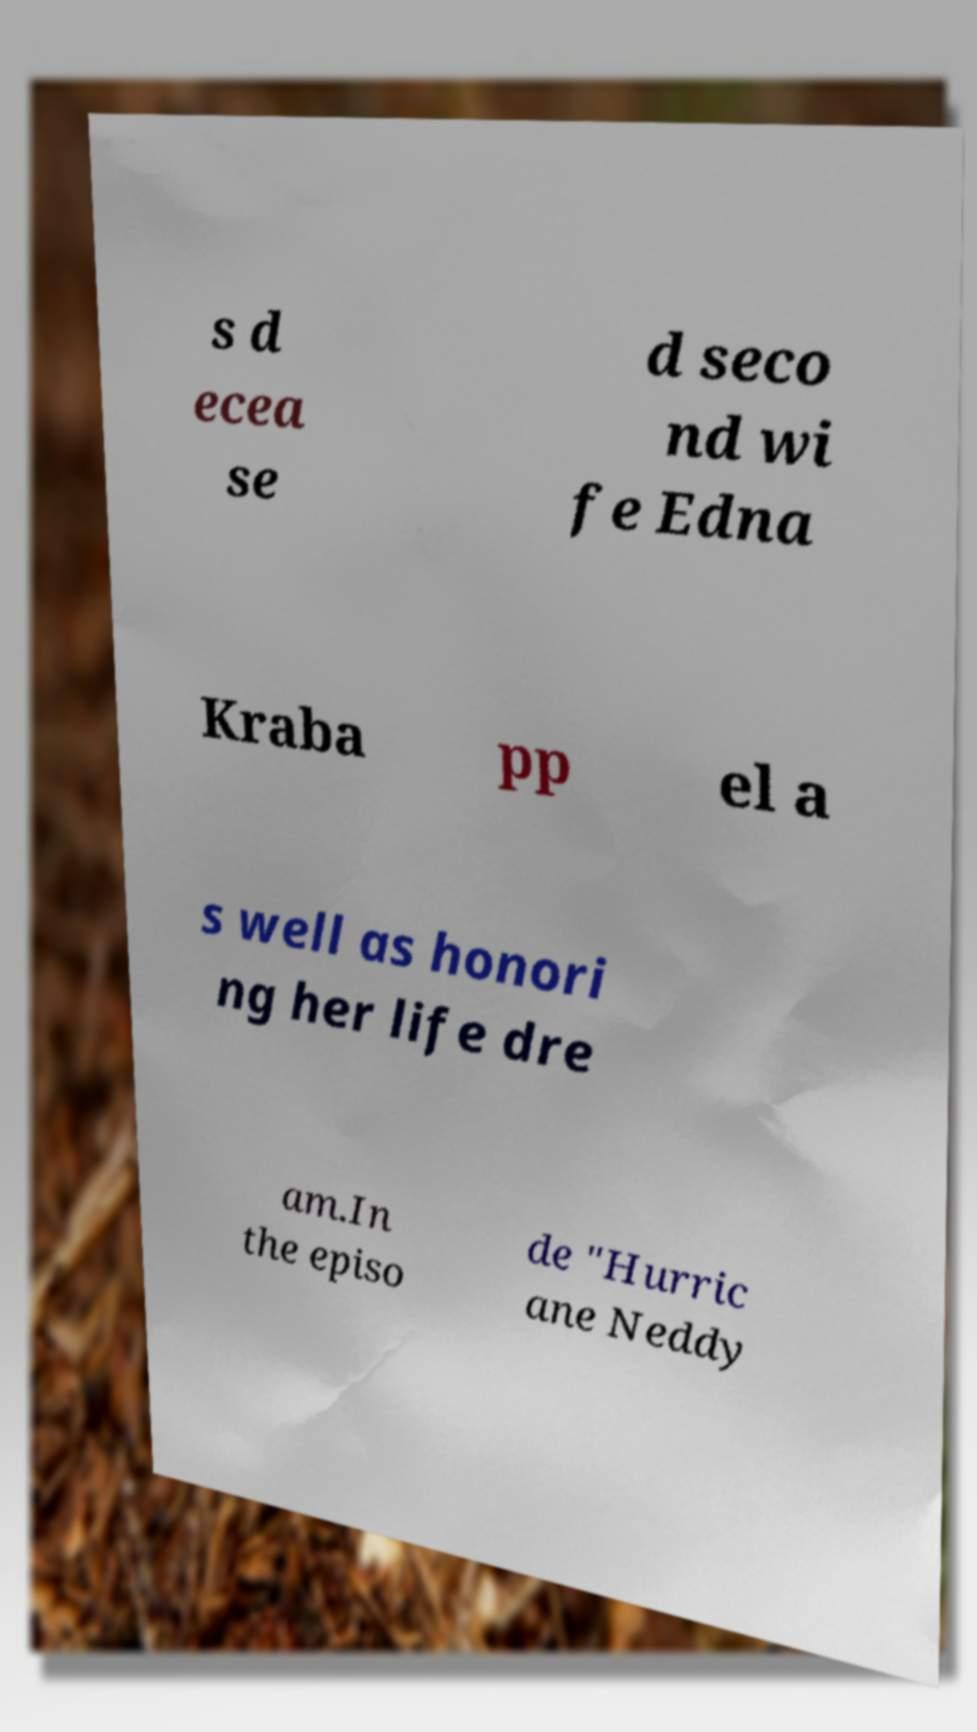Could you assist in decoding the text presented in this image and type it out clearly? s d ecea se d seco nd wi fe Edna Kraba pp el a s well as honori ng her life dre am.In the episo de "Hurric ane Neddy 